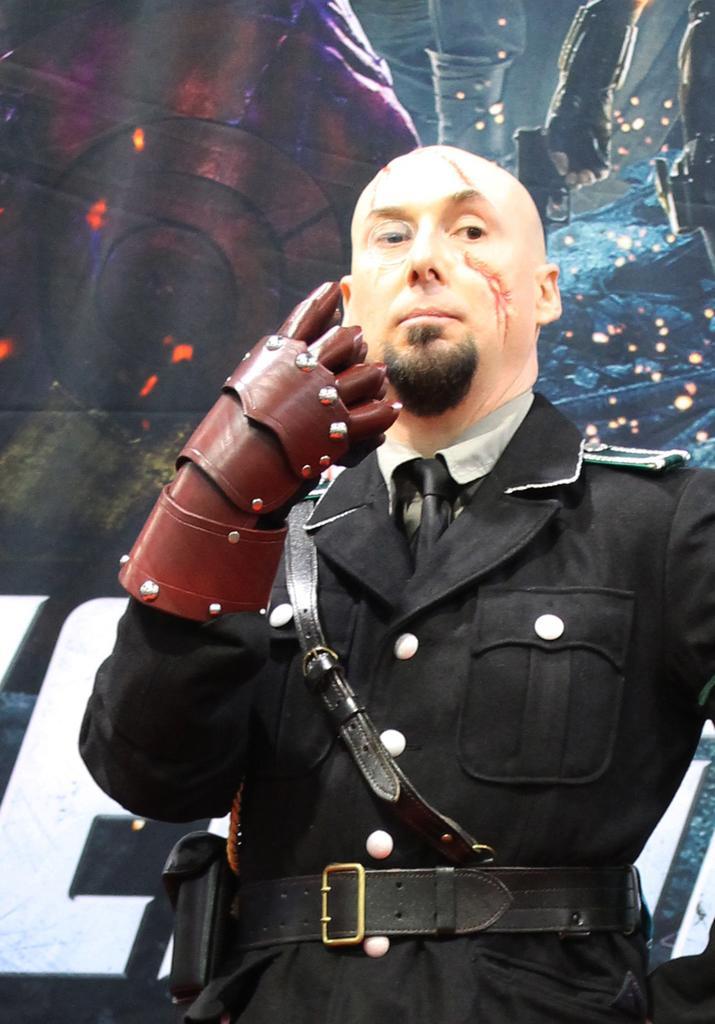Can you describe this image briefly? Here we can see a man standing and there is a glove to one of his hand. In the background we can see a hoarding. 